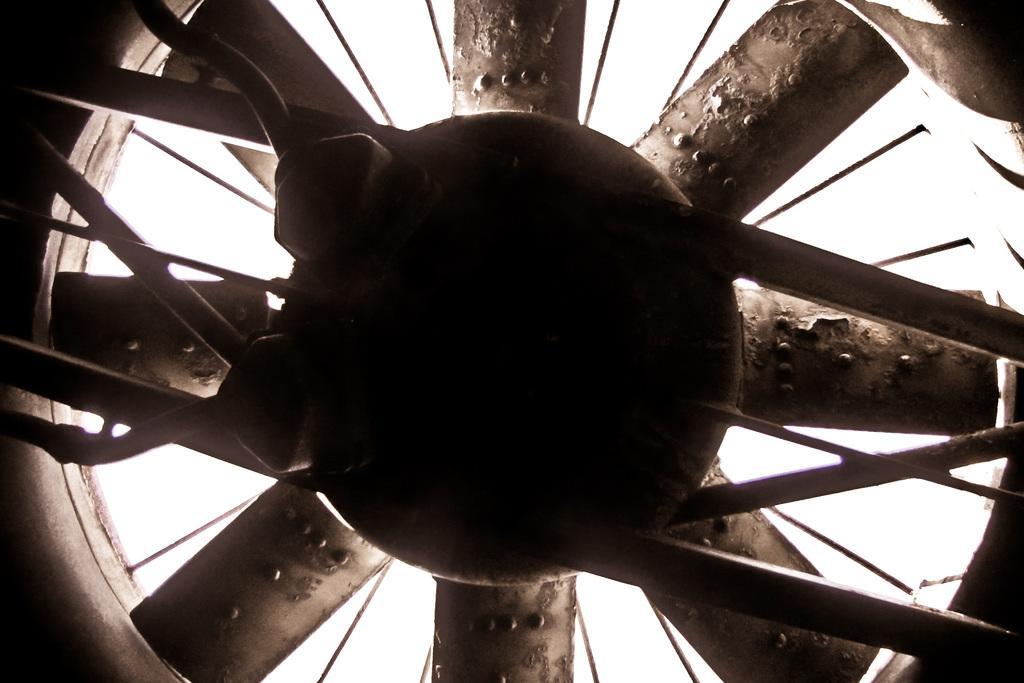Can you describe this image briefly? In this image we can see a fan. The background is white. 